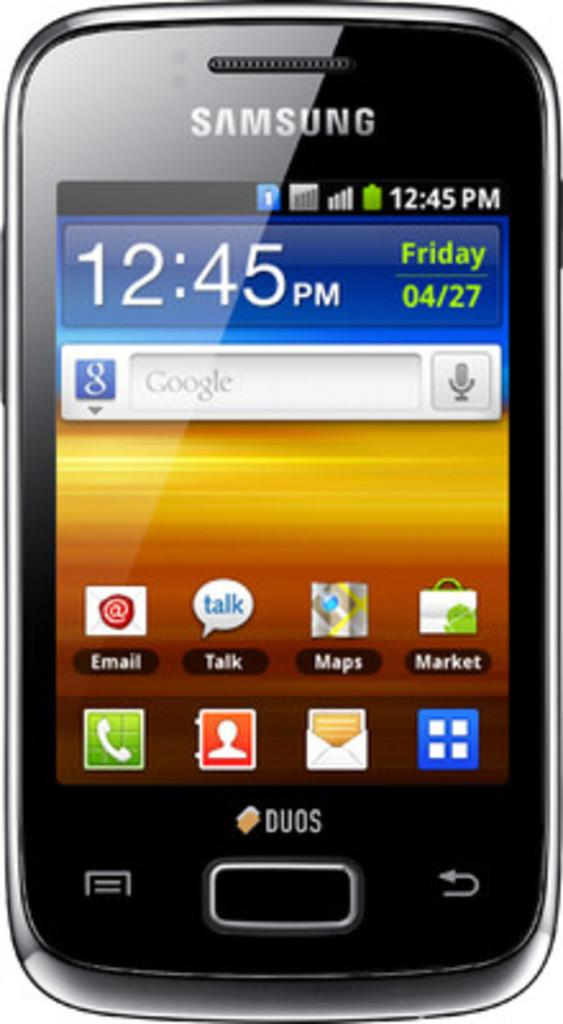What electronic device is visible in the image? There is a mobile phone in the image. What can be seen on the screen of the mobile phone? There is text on the mobile phone, and the time and date are displayed. What is the color of the background in the image? The background of the image is white in color. Is there a servant holding the mobile phone in the image? There is no servant present in the image, and the mobile phone is not being held by anyone. 